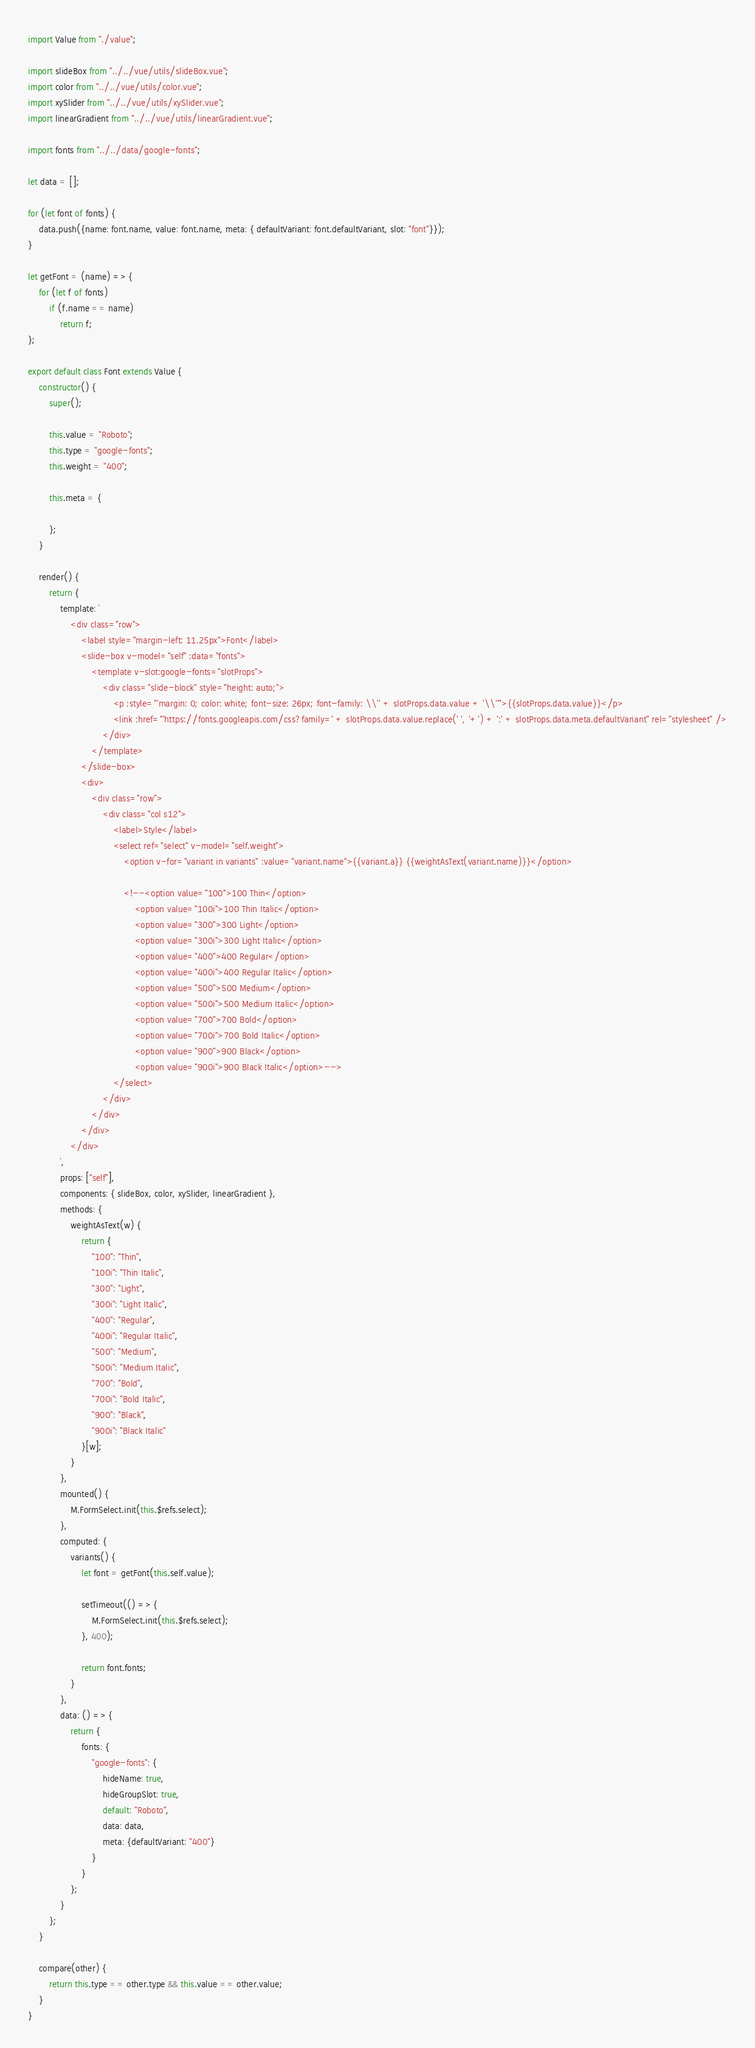Convert code to text. <code><loc_0><loc_0><loc_500><loc_500><_JavaScript_>import Value from "./value";

import slideBox from "../../vue/utils/slideBox.vue";
import color from "../../vue/utils/color.vue";
import xySlider from "../../vue/utils/xySlider.vue";
import linearGradient from "../../vue/utils/linearGradient.vue";

import fonts from "../../data/google-fonts";

let data = [];

for (let font of fonts) {
	data.push({name: font.name, value: font.name, meta: { defaultVariant: font.defaultVariant, slot: "font"}});
}

let getFont = (name) => {
	for (let f of fonts)
		if (f.name == name)
			return f;
};

export default class Font extends Value {
	constructor() {
		super();

		this.value = "Roboto";
		this.type = "google-fonts";
		this.weight = "400";

		this.meta = {
			
		};
	}

	render() {
		return {
			template: `
				<div class="row">
					<label style="margin-left: 11.25px">Font</label>
					<slide-box v-model="self" :data="fonts">
						<template v-slot:google-fonts="slotProps">
							<div class="slide-block" style="height: auto;">
								<p :style="'margin: 0; color: white; font-size: 26px; font-family: \\'' + slotProps.data.value + '\\''">{{slotProps.data.value}}</p>
								<link :href="'https://fonts.googleapis.com/css?family=' + slotProps.data.value.replace(' ', '+') + ':' + slotProps.data.meta.defaultVariant" rel="stylesheet" />
							</div>
						</template>
					</slide-box>
					<div>
						<div class="row">
							<div class="col s12">
								<label>Style</label>
								<select ref="select" v-model="self.weight">
									<option v-for="variant in variants" :value="variant.name">{{variant.a}} {{weightAsText(variant.name)}}</option>

									<!--<option value="100">100 Thin</option>
										<option value="100i">100 Thin Italic</option>
										<option value="300">300 Light</option>
										<option value="300i">300 Light Italic</option>
										<option value="400">400 Regular</option>
										<option value="400i">400 Regular Italic</option>
										<option value="500">500 Medium</option>
										<option value="500i">500 Medium Italic</option>
										<option value="700">700 Bold</option>
										<option value="700i">700 Bold Italic</option>
										<option value="900">900 Black</option>
										<option value="900i">900 Black Italic</option>-->
								</select>
							</div>
						</div>
					</div>
				</div>
			`,
			props: ["self"],
			components: { slideBox, color, xySlider, linearGradient },
			methods: {
				weightAsText(w) {
					return {
						"100": "Thin",
						"100i": "Thin Italic",
						"300": "Light",
						"300i": "Light Italic",
						"400": "Regular",
						"400i": "Regular Italic",
						"500": "Medium",
						"500i": "Medium Italic",
						"700": "Bold",
						"700i": "Bold Italic",
						"900": "Black",
						"900i": "Black Italic"
					}[w];
				}
			},
			mounted() {
				M.FormSelect.init(this.$refs.select);
			},
			computed: {
				variants() {
					let font = getFont(this.self.value);

					setTimeout(() => {
						M.FormSelect.init(this.$refs.select);
					}, 400);

					return font.fonts;
				}
			},
			data: () => {
				return {
					fonts: {
						"google-fonts": {
							hideName: true,
							hideGroupSlot: true,
							default: "Roboto",
							data: data,
							meta: {defaultVariant: "400"}
						}
					}
				};
			}
		};
	}

	compare(other) {
		return this.type == other.type && this.value == other.value;
	}
}</code> 